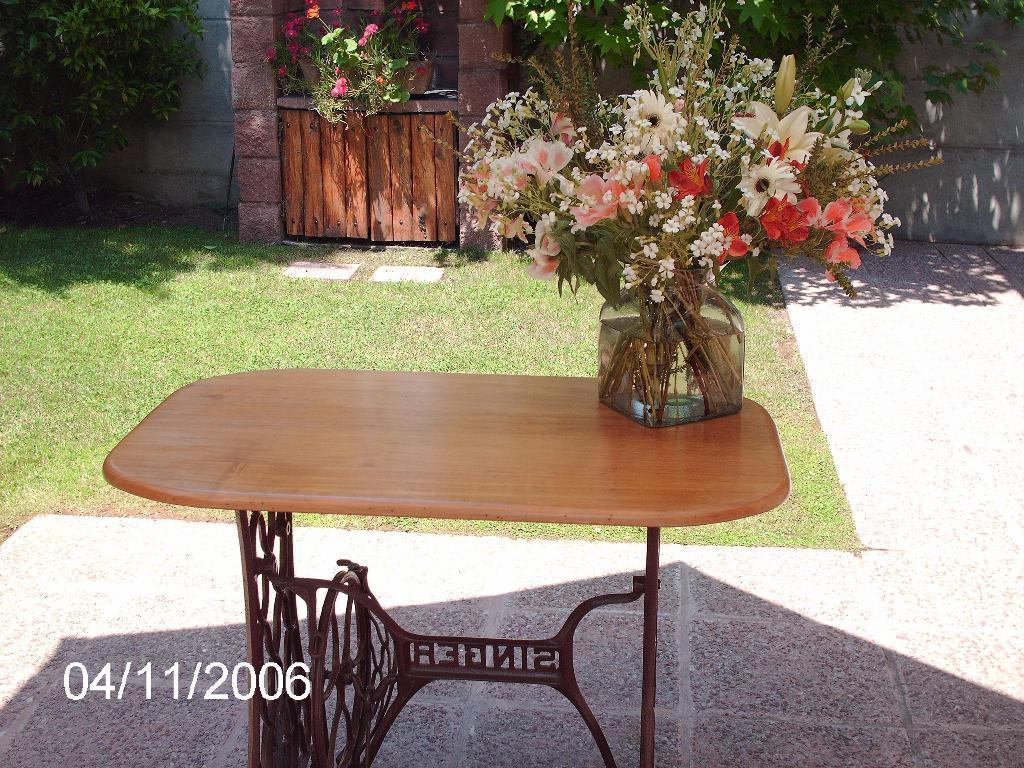Can you describe this image briefly? A flower vase is kept on a table. Beside there is a grass patch. A door is decorated with a bouquet in the background. There are some plants beside the door. 